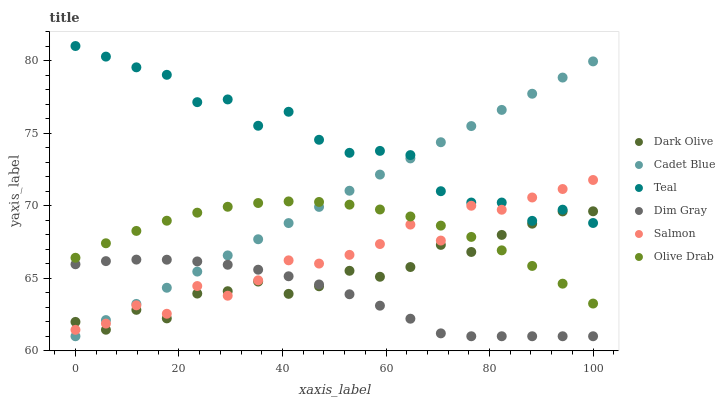Does Dim Gray have the minimum area under the curve?
Answer yes or no. Yes. Does Teal have the maximum area under the curve?
Answer yes or no. Yes. Does Dark Olive have the minimum area under the curve?
Answer yes or no. No. Does Dark Olive have the maximum area under the curve?
Answer yes or no. No. Is Cadet Blue the smoothest?
Answer yes or no. Yes. Is Teal the roughest?
Answer yes or no. Yes. Is Dark Olive the smoothest?
Answer yes or no. No. Is Dark Olive the roughest?
Answer yes or no. No. Does Cadet Blue have the lowest value?
Answer yes or no. Yes. Does Dark Olive have the lowest value?
Answer yes or no. No. Does Teal have the highest value?
Answer yes or no. Yes. Does Dark Olive have the highest value?
Answer yes or no. No. Is Dim Gray less than Teal?
Answer yes or no. Yes. Is Teal greater than Olive Drab?
Answer yes or no. Yes. Does Dim Gray intersect Salmon?
Answer yes or no. Yes. Is Dim Gray less than Salmon?
Answer yes or no. No. Is Dim Gray greater than Salmon?
Answer yes or no. No. Does Dim Gray intersect Teal?
Answer yes or no. No. 